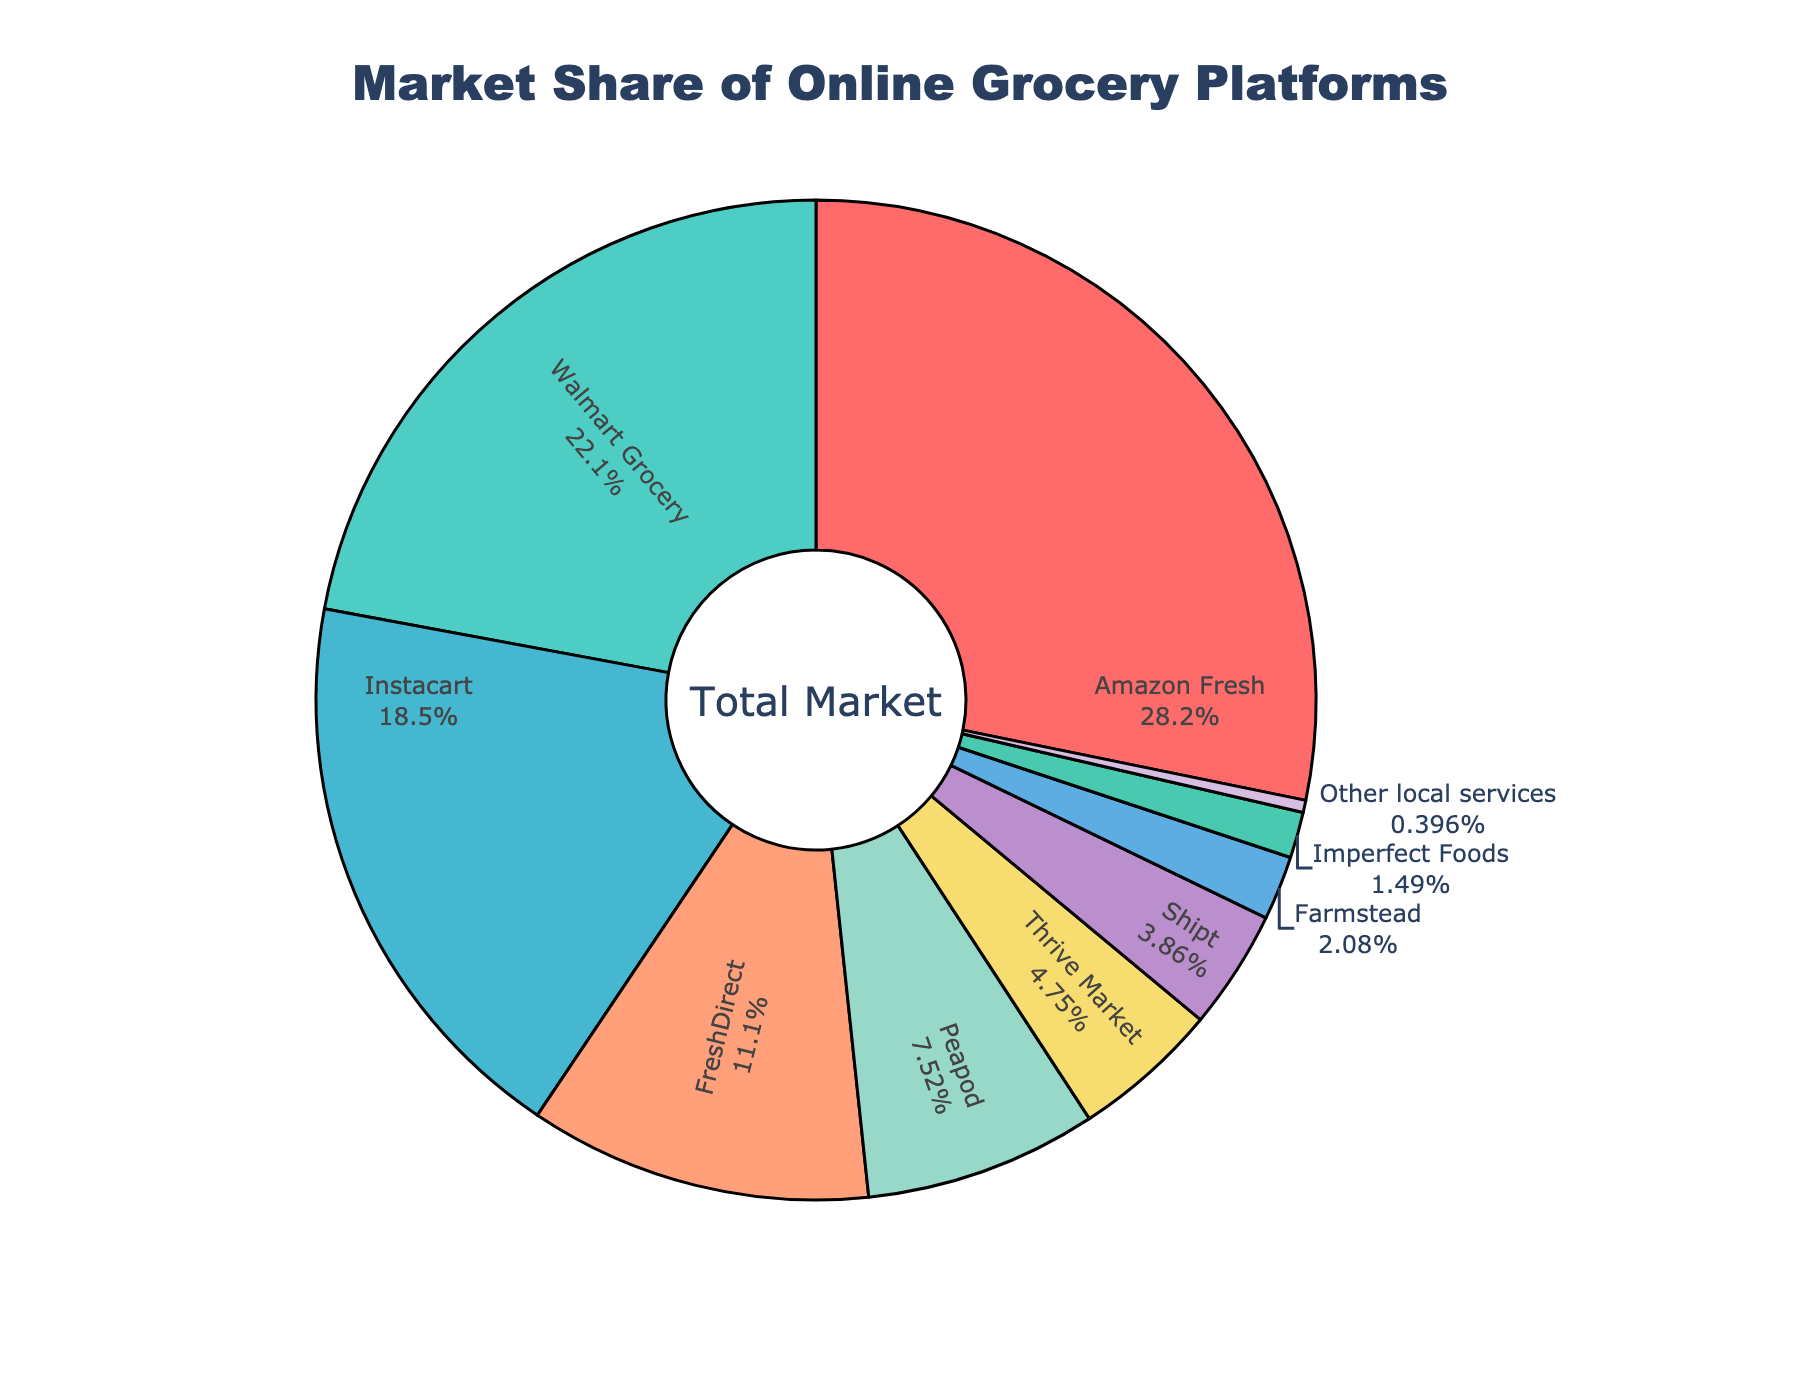What's the market share of Amazon Fresh? The market share percentage for Amazon Fresh can be directly read from the chart.
Answer: 28.5% Which platforms make up more than 20% of the market share? By examining the pie slices and their associated labels, Amazon Fresh (28.5%) and Walmart Grocery (22.3%) are both above 20%.
Answer: Amazon Fresh, Walmart Grocery How much more market share does Amazon Fresh have compared to Instacart? Subtract the market share of Instacart (18.7%) from that of Amazon Fresh (28.5%). 28.5 - 18.7 = 9.8
Answer: 9.8% Which platform has the smallest market share? By identifying the smallest slice in the pie chart, "Other local services" has the smallest market share of 0.4%.
Answer: Other local services What is the total market share of platforms with less than 5%? Sum the market shares of Peapod (7.6%), Thrive Market (4.8%), Shipt (3.9%), Farmstead (2.1%), and Imperfect Foods (1.5%). 4.8 + 3.9 + 2.1 + 1.5 = 12.3
Answer: 12.3% Comparing Instacart and FreshDirect, which one has the higher market share? From the chart, Instacart has 18.7%, while FreshDirect has 11.2%. Instacart's percentage is higher.
Answer: Instacart Among Peapod, Thrive Market, and Shipt, which platform has the largest market share? Comparing the percentages: Peapod (7.6%), Thrive Market (4.8%), and Shipt (3.9%). Peapod has the highest percentage.
Answer: Peapod What percentage of the market do Amazon Fresh and Walmart Grocery collectively hold? Add the market share percentages of Amazon Fresh (28.5%) and Walmart Grocery (22.3%). 28.5 + 22.3 = 50.8
Answer: 50.8% Which platform is represented by the red color in the pie chart? By looking at the color coding in the chart, the red color is associated with Amazon Fresh.
Answer: Amazon Fresh What is the combined market share of FreshDirect and Peapod? Add the market shares of FreshDirect (11.2%) and Peapod (7.6%). 11.2 + 7.6 = 18.8
Answer: 18.8% 